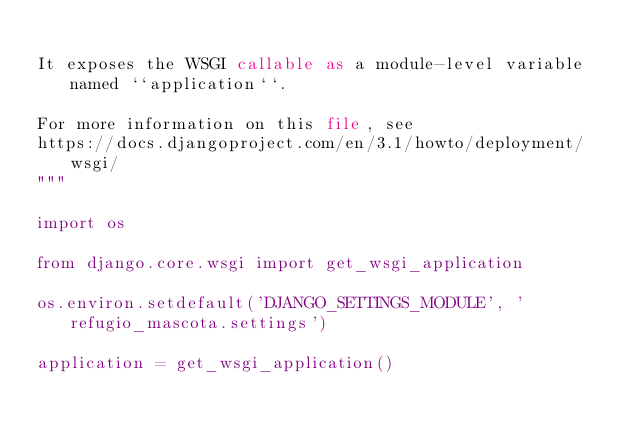<code> <loc_0><loc_0><loc_500><loc_500><_Python_>
It exposes the WSGI callable as a module-level variable named ``application``.

For more information on this file, see
https://docs.djangoproject.com/en/3.1/howto/deployment/wsgi/
"""

import os

from django.core.wsgi import get_wsgi_application

os.environ.setdefault('DJANGO_SETTINGS_MODULE', 'refugio_mascota.settings')

application = get_wsgi_application()
</code> 